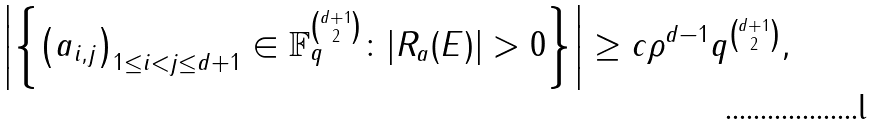<formula> <loc_0><loc_0><loc_500><loc_500>\left | \left \{ \left ( a _ { i , j } \right ) _ { 1 \leq i < j \leq d + 1 } \in \mathbb { F } _ { q } ^ { d + 1 \choose 2 } \colon | R _ { a } ( E ) | > 0 \right \} \right | \geq c \rho ^ { d - 1 } q ^ { d + 1 \choose 2 } ,</formula> 